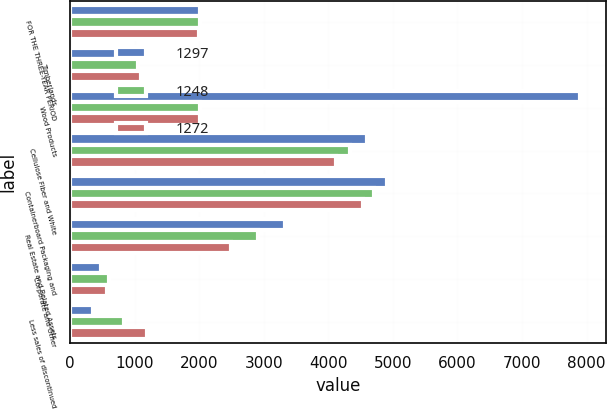<chart> <loc_0><loc_0><loc_500><loc_500><stacked_bar_chart><ecel><fcel>FOR THE THREE-YEAR PERIOD<fcel>Timberlands<fcel>Wood Products<fcel>Cellulose Fiber and White<fcel>Containerboard Packaging and<fcel>Real Estate and Related Assets<fcel>Corporate and Other<fcel>Less sales of discontinued<nl><fcel>1297<fcel>2006<fcel>1016<fcel>7902<fcel>4601<fcel>4912<fcel>3335<fcel>484<fcel>354<nl><fcel>1248<fcel>2005<fcel>1047<fcel>2005.5<fcel>4336<fcel>4707<fcel>2915<fcel>600<fcel>837<nl><fcel>1272<fcel>2004<fcel>1102<fcel>2005.5<fcel>4115<fcel>4535<fcel>2495<fcel>575<fcel>1186<nl></chart> 